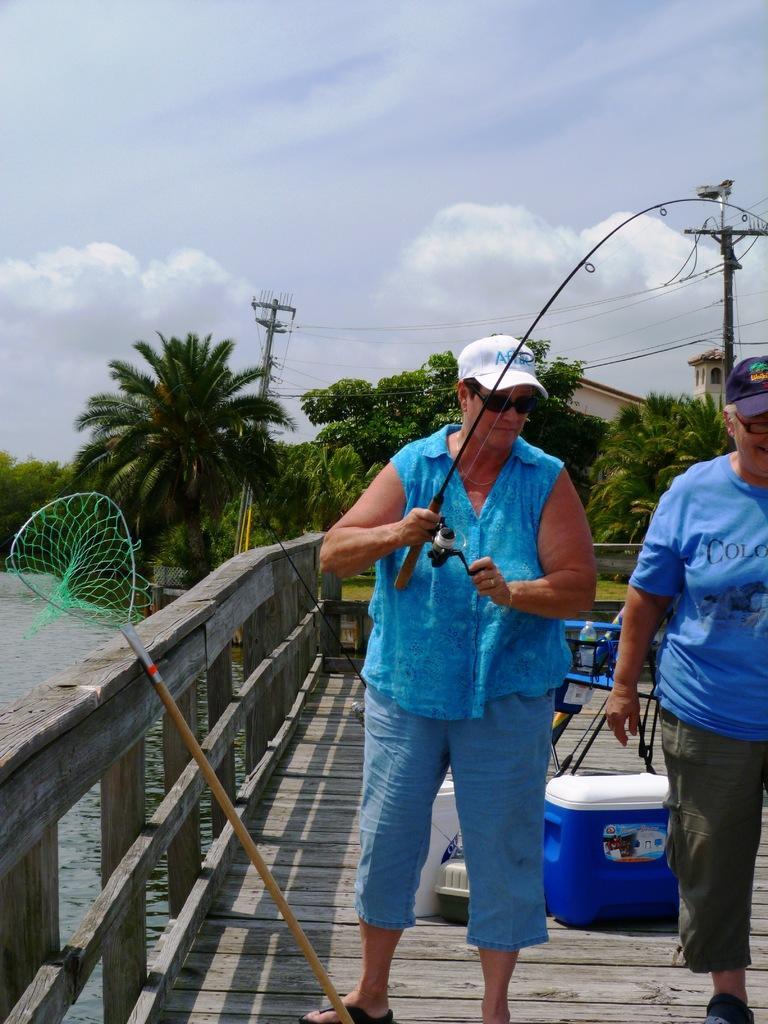Could you give a brief overview of what you see in this image? Sky is cloudy. Here we can see people. Background there are trees, current poles, water and objects. 